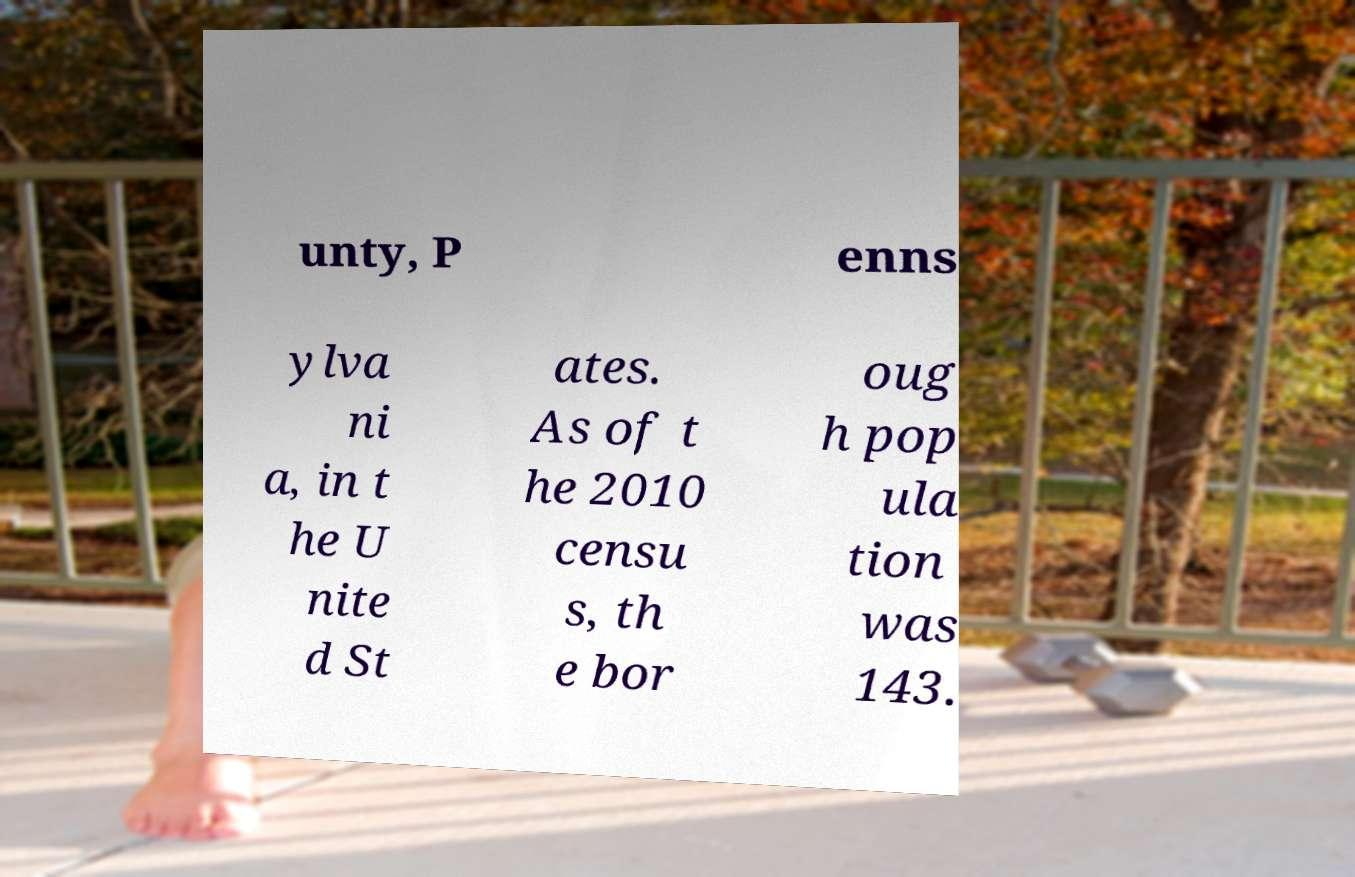Could you extract and type out the text from this image? unty, P enns ylva ni a, in t he U nite d St ates. As of t he 2010 censu s, th e bor oug h pop ula tion was 143. 